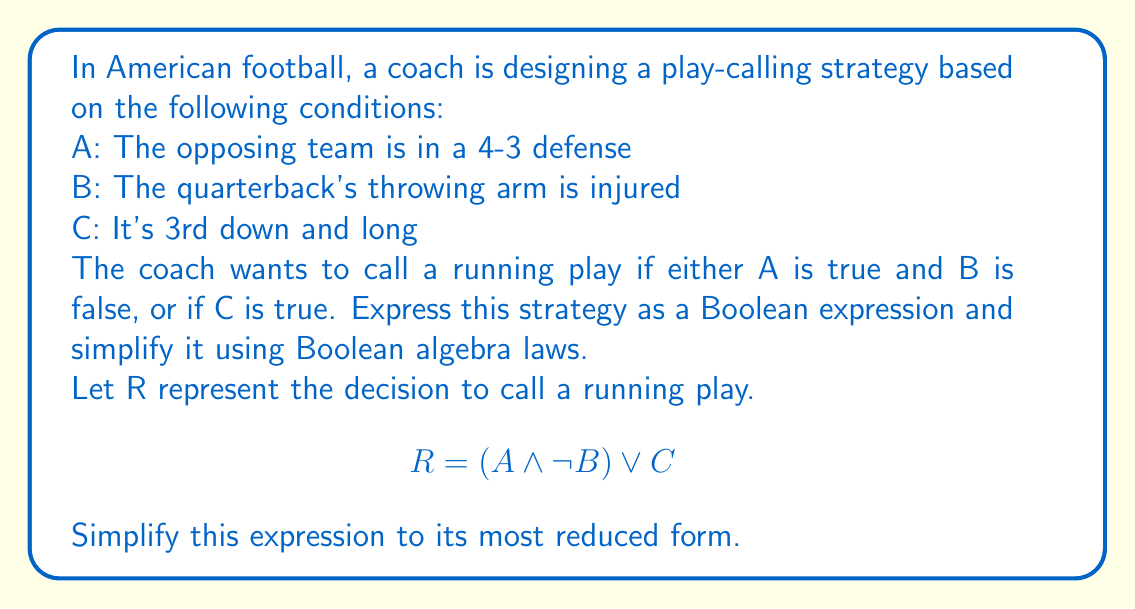Solve this math problem. Let's simplify the given Boolean expression step by step:

1) Start with the original expression:
   $R = (A \wedge \neg B) \vee C$

2) Apply the distributive law:
   $R = (A \vee C) \wedge (\neg B \vee C)$

3) In the second term, we can apply the absorption law:
   $\neg B \vee C = \neg B \vee C \vee (C \wedge B)$

4) Rearrange the terms:
   $\neg B \vee C = (\neg B \vee C) \vee (C \wedge B)$

5) Apply the distributive law again:
   $\neg B \vee C = C \vee (\neg B \vee B)$

6) Simplify using the law of excluded middle ($\neg B \vee B = 1$):
   $\neg B \vee C = C \vee 1 = 1$

7) Substitute this result back into our expression from step 2:
   $R = (A \vee C) \wedge 1$

8) Simplify using the identity law ($X \wedge 1 = X$):
   $R = A \vee C$

This simplified expression means that a running play will be called if either the opposing team is in a 4-3 defense (A) or it's 3rd down and long (C), regardless of the quarterback's arm injury status.
Answer: $R = A \vee C$ 